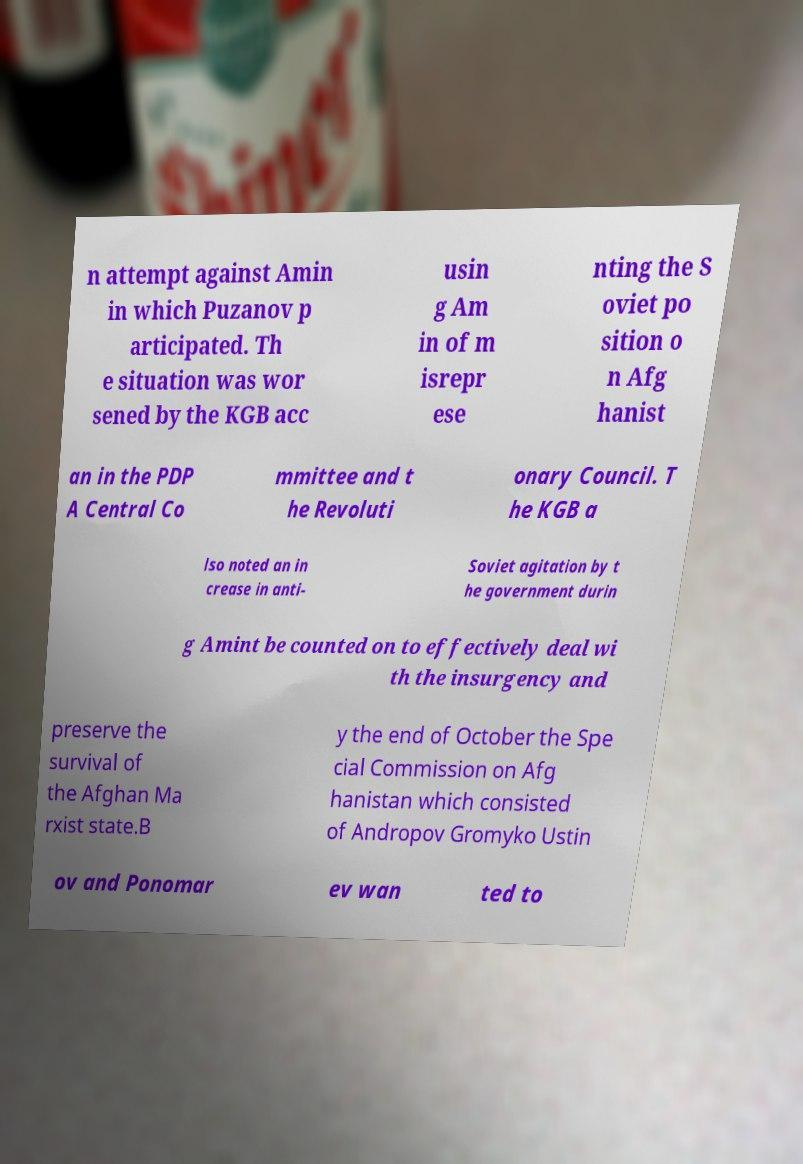There's text embedded in this image that I need extracted. Can you transcribe it verbatim? n attempt against Amin in which Puzanov p articipated. Th e situation was wor sened by the KGB acc usin g Am in of m isrepr ese nting the S oviet po sition o n Afg hanist an in the PDP A Central Co mmittee and t he Revoluti onary Council. T he KGB a lso noted an in crease in anti- Soviet agitation by t he government durin g Amint be counted on to effectively deal wi th the insurgency and preserve the survival of the Afghan Ma rxist state.B y the end of October the Spe cial Commission on Afg hanistan which consisted of Andropov Gromyko Ustin ov and Ponomar ev wan ted to 